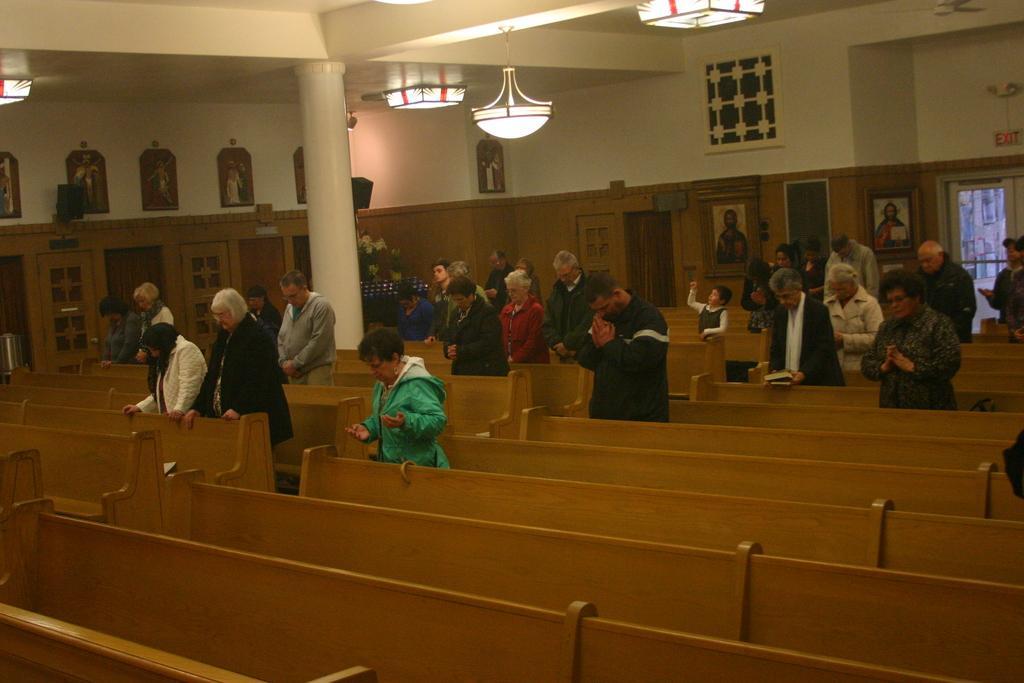How would you summarize this image in a sentence or two? In this image it seems like there are few people standing in the church and praying. At the top there is a chandelier and there are lights at the top. In the middle there is a pillar. There are photo frames attached to the wall. On the right side top there is an exit board. On the left side there are sculptures attached to the wall. 